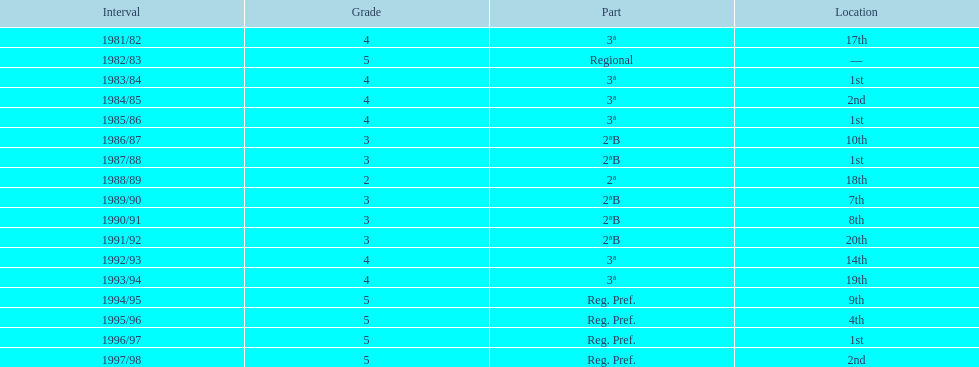How many years were they in tier 3 5. 